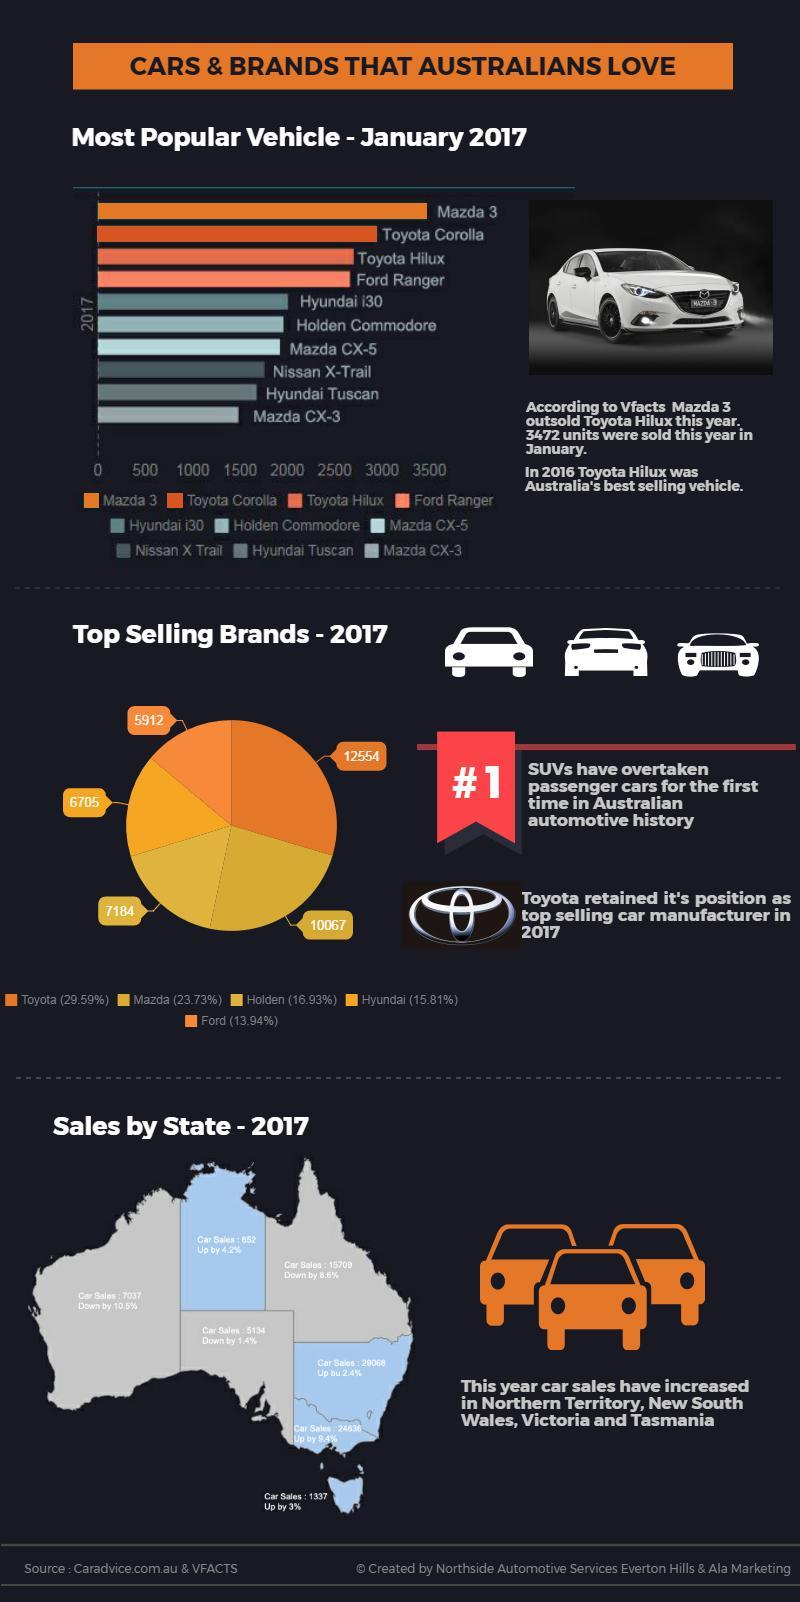How many cars were sold in the right most island region?
Answer the question with a short phrase. 1337 How many cars of Hyundai were sold in Australia in 2017? 6705 How many cars of the brand which holds second position in most selling brands were sold in 2017? 10067 How many cars of Holden were sold in Australia in 2017? 7184 Which brand holds third position in most selling brands? Holden What is the percentage difference in the car sale between New South Wales and Victoria? 7 What is the name of the island state of Australia? Tasmania Which car brand holds the fifth position among famous brands in Australia? Hyundai i30 How many cars of the brand Toyota were sold in the year 2017? 12554 What is the name of the south east region of Australia shown in blue color? Victoria 